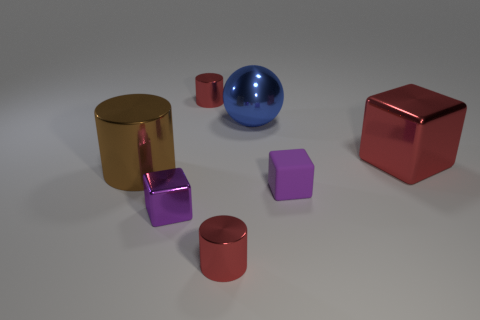Subtract all tiny red cylinders. How many cylinders are left? 1 Subtract all green cylinders. How many purple blocks are left? 2 Subtract all red cylinders. How many cylinders are left? 1 Add 1 purple matte spheres. How many objects exist? 8 Subtract all cubes. How many objects are left? 4 Subtract 1 cubes. How many cubes are left? 2 Subtract all big blue objects. Subtract all tiny shiny blocks. How many objects are left? 5 Add 4 big brown metallic cylinders. How many big brown metallic cylinders are left? 5 Add 5 big brown matte spheres. How many big brown matte spheres exist? 5 Subtract 1 blue spheres. How many objects are left? 6 